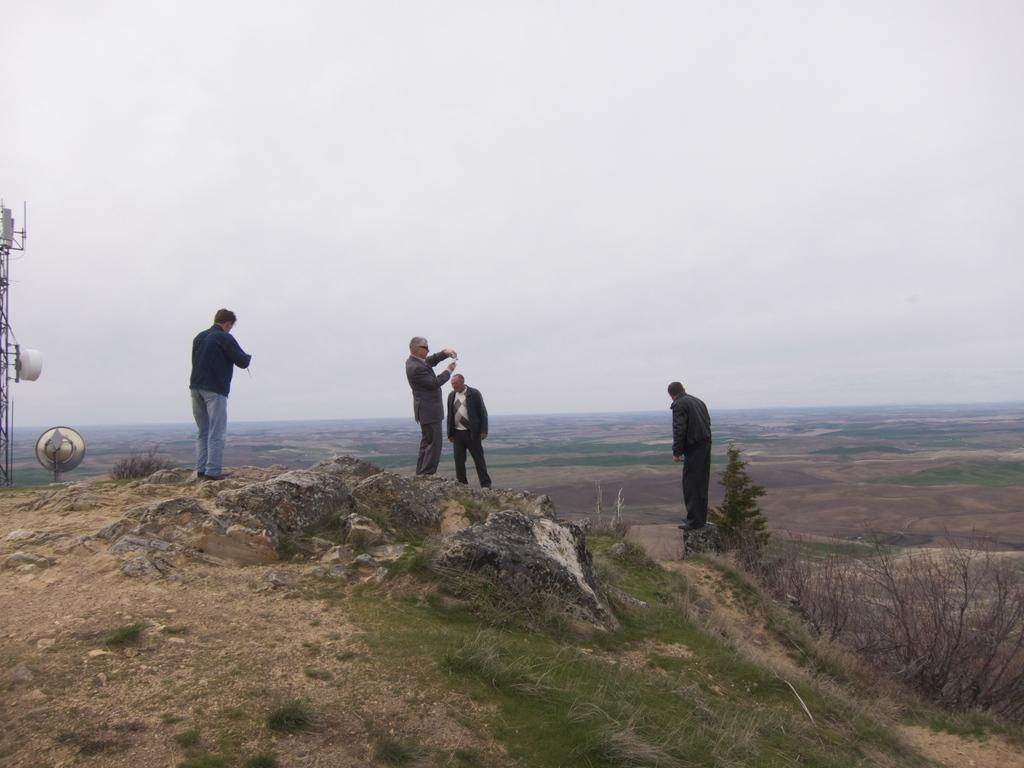What are the people in the image doing? The people in the image are standing on a hill. What can be seen on the right side of the image? There is a bush on the right side of the image. What is visible in the background of the image? The sky is visible in the background of the image. What type of animals can be seen in the zoo in the image? There is no zoo present in the image; it features people standing on a hill with a bush and a visible sky in the background. 